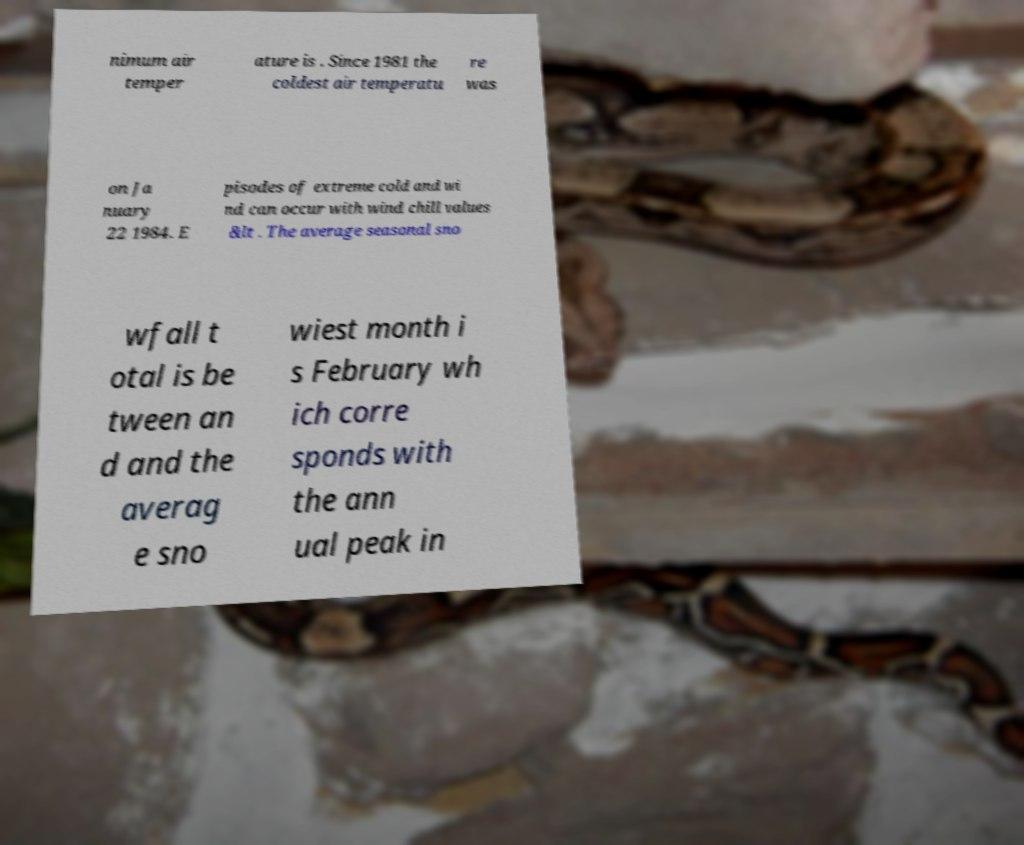Please read and relay the text visible in this image. What does it say? nimum air temper ature is . Since 1981 the coldest air temperatu re was on Ja nuary 22 1984. E pisodes of extreme cold and wi nd can occur with wind chill values &lt . The average seasonal sno wfall t otal is be tween an d and the averag e sno wiest month i s February wh ich corre sponds with the ann ual peak in 